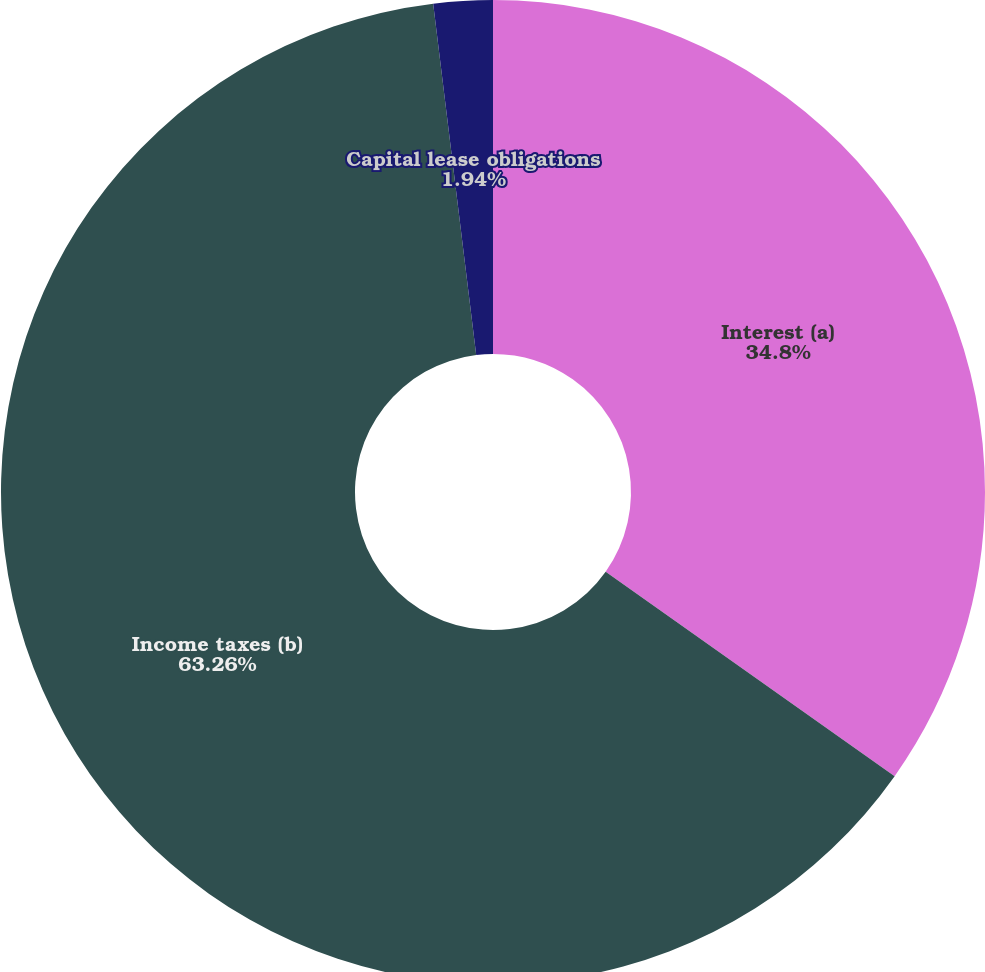Convert chart. <chart><loc_0><loc_0><loc_500><loc_500><pie_chart><fcel>Interest (a)<fcel>Income taxes (b)<fcel>Capital lease obligations<nl><fcel>34.8%<fcel>63.26%<fcel>1.94%<nl></chart> 